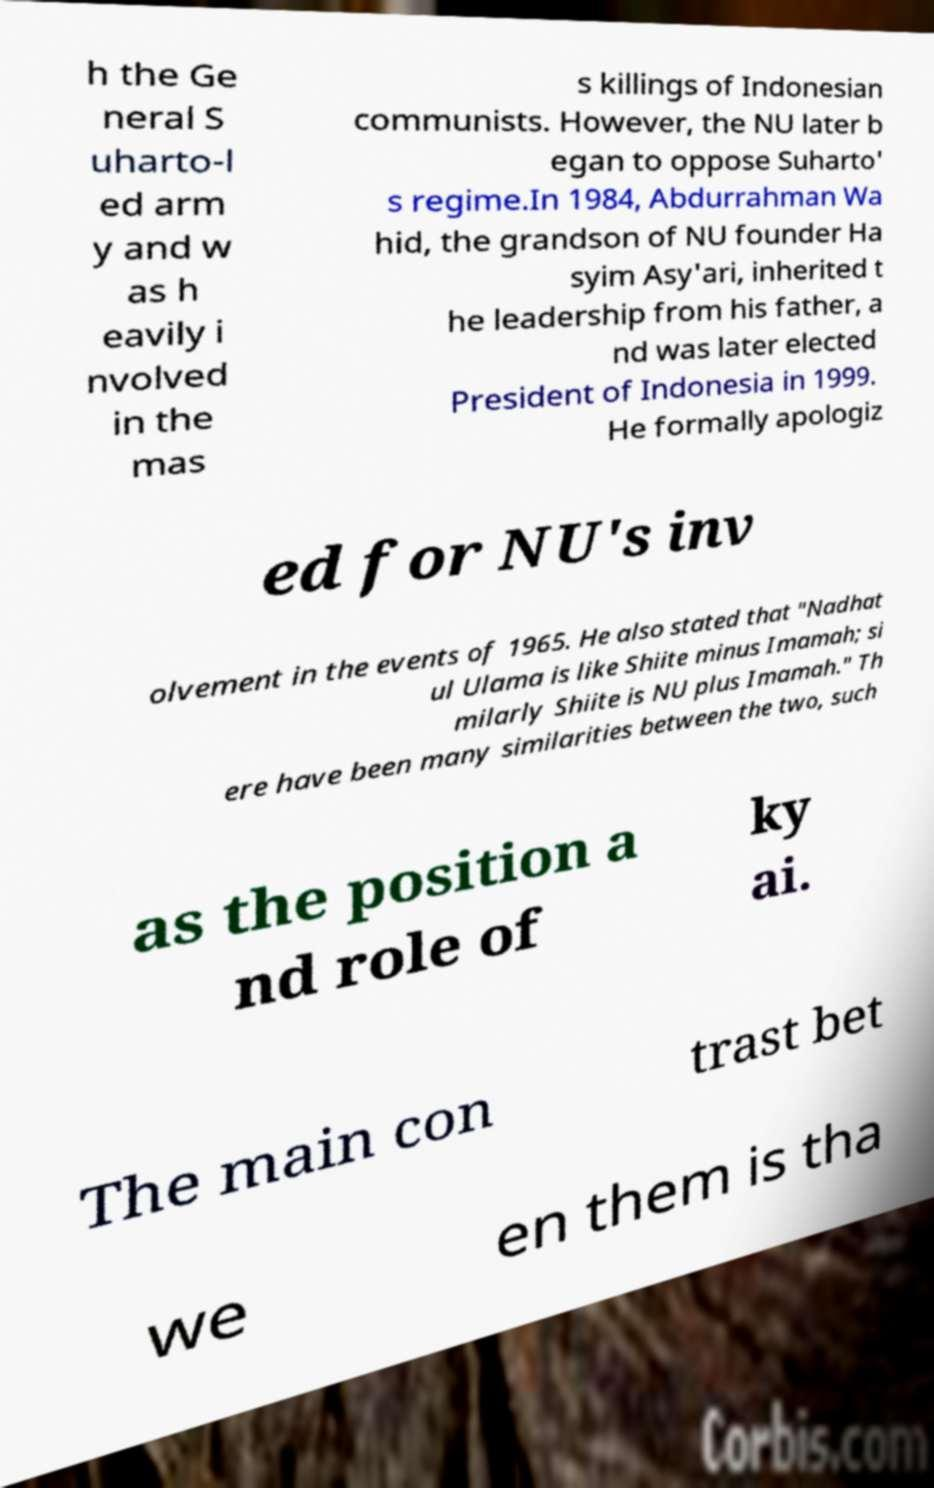I need the written content from this picture converted into text. Can you do that? h the Ge neral S uharto-l ed arm y and w as h eavily i nvolved in the mas s killings of Indonesian communists. However, the NU later b egan to oppose Suharto' s regime.In 1984, Abdurrahman Wa hid, the grandson of NU founder Ha syim Asy'ari, inherited t he leadership from his father, a nd was later elected President of Indonesia in 1999. He formally apologiz ed for NU's inv olvement in the events of 1965. He also stated that "Nadhat ul Ulama is like Shiite minus Imamah; si milarly Shiite is NU plus Imamah." Th ere have been many similarities between the two, such as the position a nd role of ky ai. The main con trast bet we en them is tha 